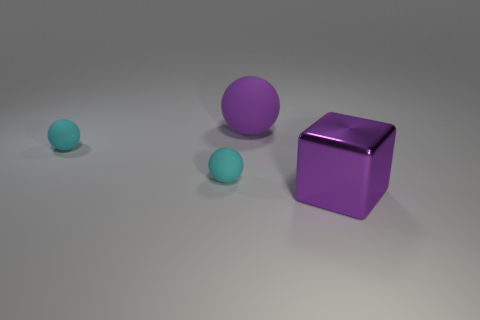Imagine these objects represent family members. What family roles could they symbolize, and why? In an imaginative interpretation, the larger purple cube could represent the head of the family, standing strong and central. The two cyan spheres might represent the children, with the smaller one being the youngest family member, symbolically looking up to the more mature sibling represented by the slightly larger sphere. 